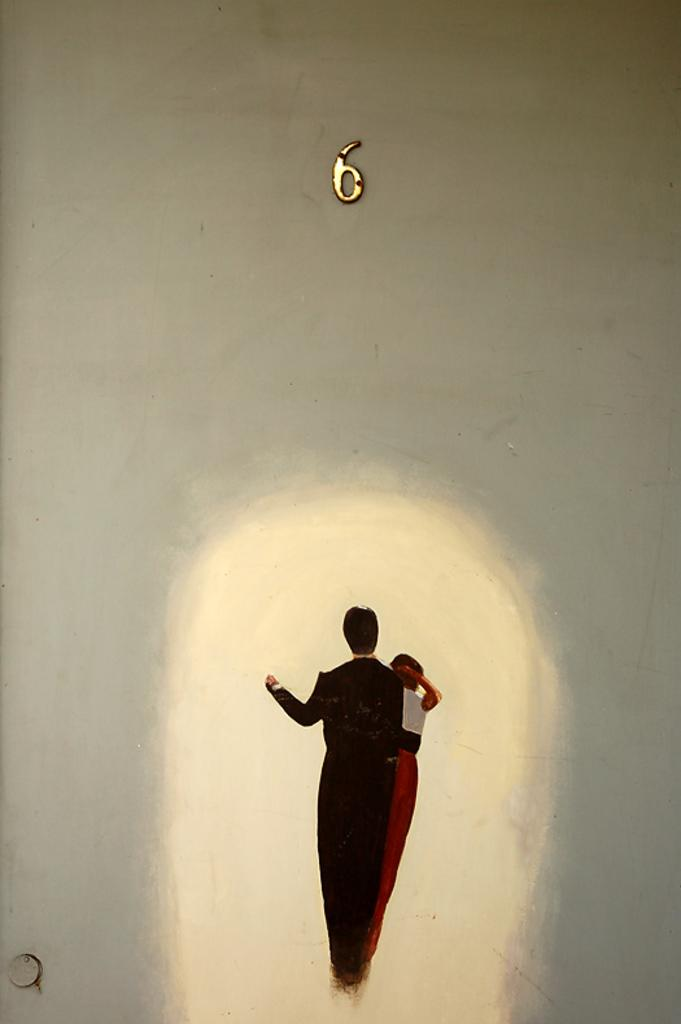How many people are in the image? There are two people in the image. What are the people wearing? The people are wearing different color dresses. What can be seen in the background of the image? There is a white wall in the background of the image. Is there any text or number visible on the wall? Yes, the number 6 is written on the wall. What type of ground can be seen beneath the people in the image? There is no ground visible in the image; it appears to be an indoor setting with a white wall in the background. 